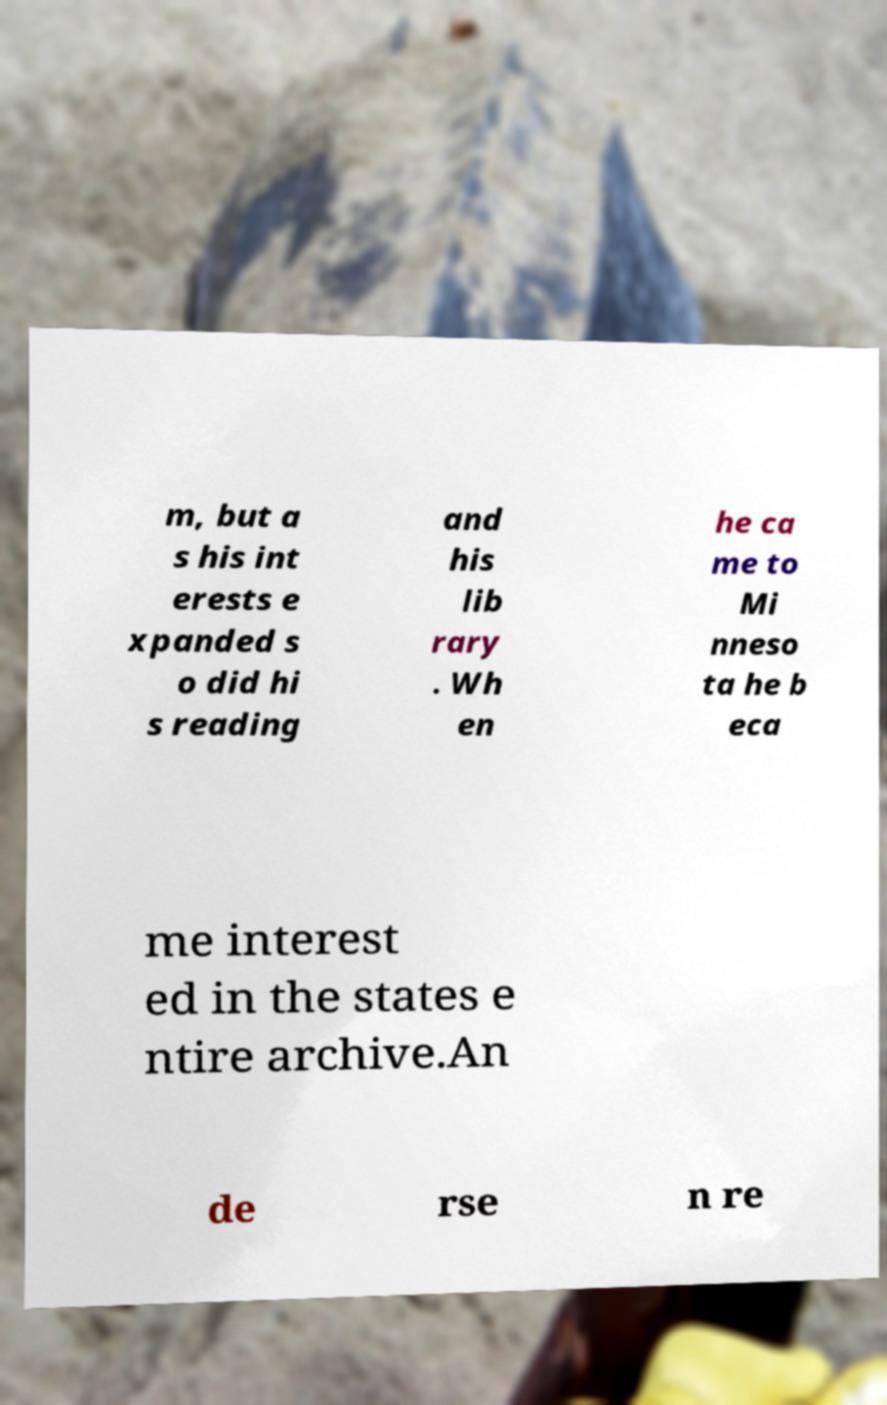For documentation purposes, I need the text within this image transcribed. Could you provide that? m, but a s his int erests e xpanded s o did hi s reading and his lib rary . Wh en he ca me to Mi nneso ta he b eca me interest ed in the states e ntire archive.An de rse n re 